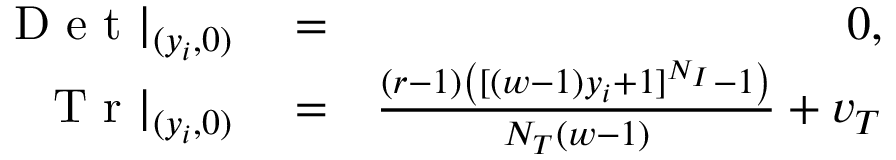Convert formula to latex. <formula><loc_0><loc_0><loc_500><loc_500>\begin{array} { r l r } { D e t | _ { ( y _ { i } , 0 ) } } & = } & { 0 , } \\ { T r | _ { ( y _ { i } , 0 ) } } & = } & { \frac { ( r - 1 ) \left ( [ ( w - 1 ) y _ { i } + 1 ] ^ { N _ { I } } - 1 \right ) } { N _ { T } ( w - 1 ) } + v _ { T } } \end{array}</formula> 